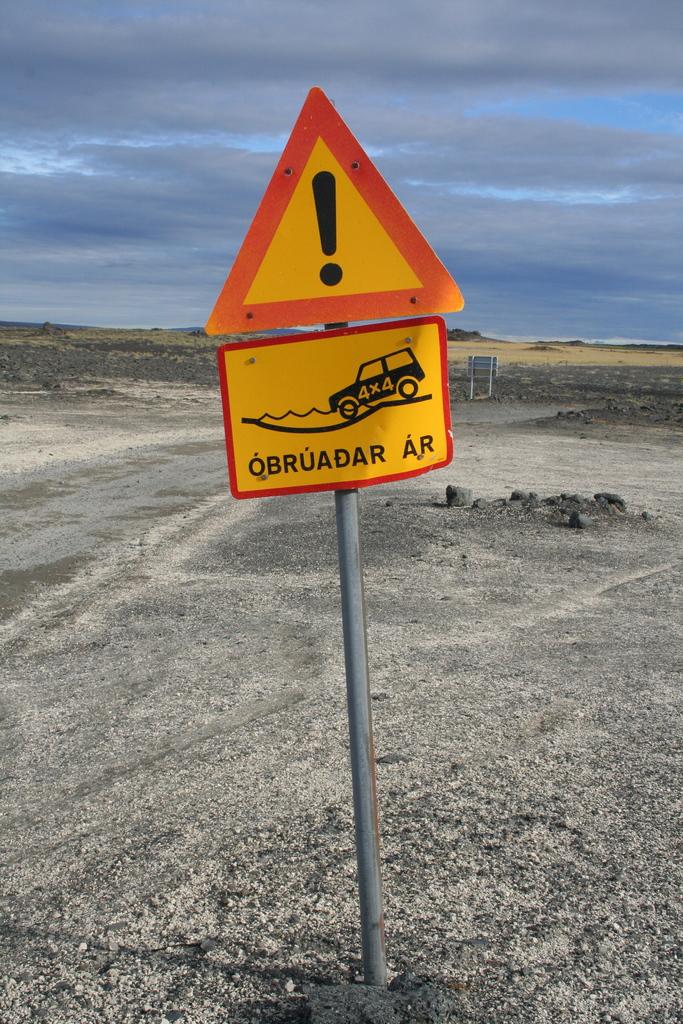What does the sign indicate?
Your answer should be very brief. Qbruadar ar. What punctuation is that on the sign?
Keep it short and to the point. !. 